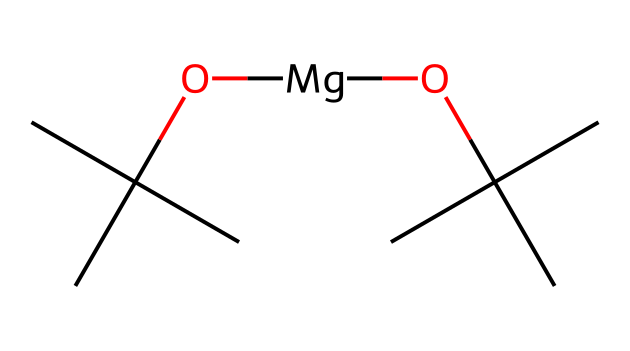What is the main functional group present in this chemical? The structure contains a hydroxyl group (–OH) as indicated by the "O" attached to a carbon atom, which identifies the compound as having alcohol functional characteristics.
Answer: hydroxyl How many carbon atoms are in the chemical structure? By examining the SMILES representation, there are a total of 8 carbon atoms present as indicated by the "C" symbols in the structure.
Answer: 8 What type of bond is primarily present between the atoms in this solvent? The chemical contains primarily single covalent bonds between the carbon and oxygen atoms, which is common in organic compounds like this solvent.
Answer: single covalent What role does the magnesium atom play in this molecule? The magnesium atom here serves as a coordinating ion, likely facilitating the solvation process by interacting with the hydroxyl groups and possibly stabilizing molecular structure.
Answer: coordinating ion Which solvent type does this chemical represent? Given the presence of long hydrocarbon chains and a polar functional group, this chemical is classified as an alcohol solvent, a common type used in various chemical applications.
Answer: alcohol What is the total degree of branching in the molecular structure? The structure indicates significant branching due to the presence of tertiary carbon atoms which are bonded to three other carbons, observed as the "C(C)(C)" features.
Answer: 3 What is the significance of having both alcohol and metal in this chemical structure? The inclusion of an alcohol component along with a metal such as magnesium suggests enhanced solubility and potential stabilization of chemical interactions, which is crucial for effective preservation properties.
Answer: enhanced solubility 